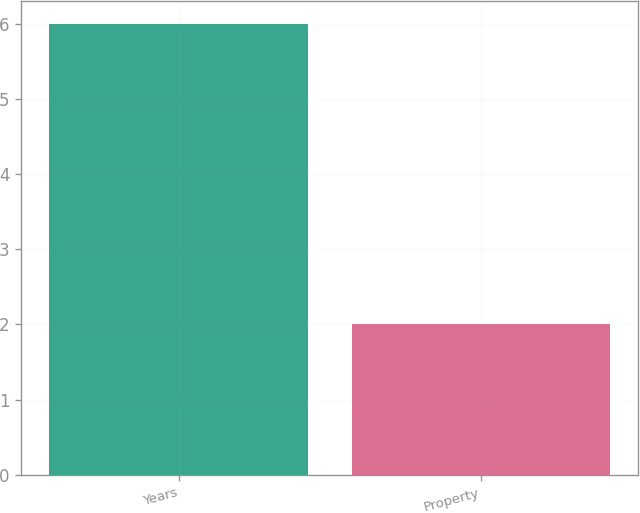Convert chart. <chart><loc_0><loc_0><loc_500><loc_500><bar_chart><fcel>Years<fcel>Property<nl><fcel>6<fcel>2<nl></chart> 